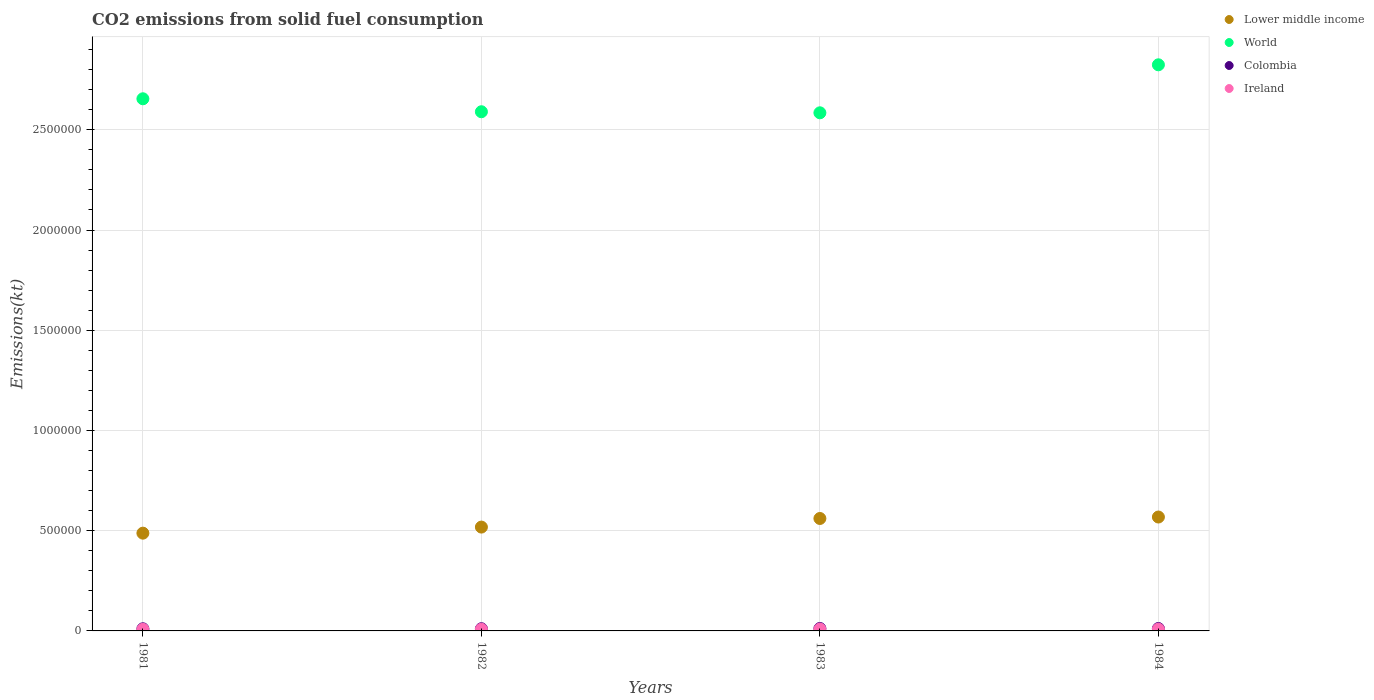What is the amount of CO2 emitted in Colombia in 1981?
Provide a short and direct response. 1.07e+04. Across all years, what is the maximum amount of CO2 emitted in World?
Your answer should be compact. 2.82e+06. Across all years, what is the minimum amount of CO2 emitted in Ireland?
Your answer should be very brief. 7920.72. What is the total amount of CO2 emitted in Lower middle income in the graph?
Ensure brevity in your answer.  2.13e+06. What is the difference between the amount of CO2 emitted in Ireland in 1983 and that in 1984?
Your response must be concise. 473.04. What is the difference between the amount of CO2 emitted in World in 1984 and the amount of CO2 emitted in Ireland in 1982?
Your answer should be very brief. 2.82e+06. What is the average amount of CO2 emitted in Colombia per year?
Give a very brief answer. 1.15e+04. In the year 1983, what is the difference between the amount of CO2 emitted in Colombia and amount of CO2 emitted in Ireland?
Offer a very short reply. 2922.6. What is the ratio of the amount of CO2 emitted in Colombia in 1981 to that in 1984?
Ensure brevity in your answer.  0.89. Is the amount of CO2 emitted in Ireland in 1983 less than that in 1984?
Offer a terse response. No. Is the difference between the amount of CO2 emitted in Colombia in 1982 and 1983 greater than the difference between the amount of CO2 emitted in Ireland in 1982 and 1983?
Ensure brevity in your answer.  No. What is the difference between the highest and the second highest amount of CO2 emitted in Lower middle income?
Give a very brief answer. 7272.31. What is the difference between the highest and the lowest amount of CO2 emitted in Colombia?
Your answer should be compact. 1477.8. Is the sum of the amount of CO2 emitted in World in 1981 and 1982 greater than the maximum amount of CO2 emitted in Ireland across all years?
Provide a short and direct response. Yes. How many dotlines are there?
Offer a very short reply. 4. Are the values on the major ticks of Y-axis written in scientific E-notation?
Your answer should be very brief. No. Does the graph contain any zero values?
Offer a very short reply. No. What is the title of the graph?
Your answer should be compact. CO2 emissions from solid fuel consumption. Does "Chad" appear as one of the legend labels in the graph?
Keep it short and to the point. No. What is the label or title of the Y-axis?
Offer a very short reply. Emissions(kt). What is the Emissions(kt) in Lower middle income in 1981?
Ensure brevity in your answer.  4.88e+05. What is the Emissions(kt) in World in 1981?
Your answer should be very brief. 2.65e+06. What is the Emissions(kt) of Colombia in 1981?
Your response must be concise. 1.07e+04. What is the Emissions(kt) of Ireland in 1981?
Your response must be concise. 7920.72. What is the Emissions(kt) in Lower middle income in 1982?
Your response must be concise. 5.18e+05. What is the Emissions(kt) in World in 1982?
Your answer should be compact. 2.59e+06. What is the Emissions(kt) in Colombia in 1982?
Offer a terse response. 1.10e+04. What is the Emissions(kt) of Ireland in 1982?
Offer a very short reply. 8360.76. What is the Emissions(kt) of Lower middle income in 1983?
Make the answer very short. 5.61e+05. What is the Emissions(kt) of World in 1983?
Your answer should be very brief. 2.58e+06. What is the Emissions(kt) of Colombia in 1983?
Offer a very short reply. 1.21e+04. What is the Emissions(kt) in Ireland in 1983?
Your response must be concise. 9226.17. What is the Emissions(kt) of Lower middle income in 1984?
Provide a succinct answer. 5.68e+05. What is the Emissions(kt) of World in 1984?
Make the answer very short. 2.82e+06. What is the Emissions(kt) of Colombia in 1984?
Offer a very short reply. 1.20e+04. What is the Emissions(kt) in Ireland in 1984?
Provide a succinct answer. 8753.13. Across all years, what is the maximum Emissions(kt) in Lower middle income?
Offer a very short reply. 5.68e+05. Across all years, what is the maximum Emissions(kt) of World?
Make the answer very short. 2.82e+06. Across all years, what is the maximum Emissions(kt) in Colombia?
Provide a short and direct response. 1.21e+04. Across all years, what is the maximum Emissions(kt) of Ireland?
Provide a succinct answer. 9226.17. Across all years, what is the minimum Emissions(kt) of Lower middle income?
Provide a short and direct response. 4.88e+05. Across all years, what is the minimum Emissions(kt) in World?
Your response must be concise. 2.58e+06. Across all years, what is the minimum Emissions(kt) of Colombia?
Make the answer very short. 1.07e+04. Across all years, what is the minimum Emissions(kt) in Ireland?
Offer a very short reply. 7920.72. What is the total Emissions(kt) of Lower middle income in the graph?
Make the answer very short. 2.13e+06. What is the total Emissions(kt) of World in the graph?
Provide a short and direct response. 1.07e+07. What is the total Emissions(kt) of Colombia in the graph?
Your answer should be compact. 4.58e+04. What is the total Emissions(kt) of Ireland in the graph?
Provide a succinct answer. 3.43e+04. What is the difference between the Emissions(kt) of Lower middle income in 1981 and that in 1982?
Provide a succinct answer. -3.03e+04. What is the difference between the Emissions(kt) of World in 1981 and that in 1982?
Keep it short and to the point. 6.47e+04. What is the difference between the Emissions(kt) of Colombia in 1981 and that in 1982?
Keep it short and to the point. -326.36. What is the difference between the Emissions(kt) of Ireland in 1981 and that in 1982?
Your answer should be very brief. -440.04. What is the difference between the Emissions(kt) in Lower middle income in 1981 and that in 1983?
Make the answer very short. -7.32e+04. What is the difference between the Emissions(kt) in World in 1981 and that in 1983?
Ensure brevity in your answer.  7.00e+04. What is the difference between the Emissions(kt) of Colombia in 1981 and that in 1983?
Make the answer very short. -1477.8. What is the difference between the Emissions(kt) of Ireland in 1981 and that in 1983?
Provide a short and direct response. -1305.45. What is the difference between the Emissions(kt) of Lower middle income in 1981 and that in 1984?
Your response must be concise. -8.05e+04. What is the difference between the Emissions(kt) of World in 1981 and that in 1984?
Keep it short and to the point. -1.70e+05. What is the difference between the Emissions(kt) in Colombia in 1981 and that in 1984?
Offer a terse response. -1334.79. What is the difference between the Emissions(kt) of Ireland in 1981 and that in 1984?
Offer a very short reply. -832.41. What is the difference between the Emissions(kt) of Lower middle income in 1982 and that in 1983?
Make the answer very short. -4.29e+04. What is the difference between the Emissions(kt) in World in 1982 and that in 1983?
Keep it short and to the point. 5262.15. What is the difference between the Emissions(kt) of Colombia in 1982 and that in 1983?
Ensure brevity in your answer.  -1151.44. What is the difference between the Emissions(kt) of Ireland in 1982 and that in 1983?
Give a very brief answer. -865.41. What is the difference between the Emissions(kt) in Lower middle income in 1982 and that in 1984?
Provide a short and direct response. -5.02e+04. What is the difference between the Emissions(kt) of World in 1982 and that in 1984?
Your response must be concise. -2.34e+05. What is the difference between the Emissions(kt) of Colombia in 1982 and that in 1984?
Ensure brevity in your answer.  -1008.42. What is the difference between the Emissions(kt) of Ireland in 1982 and that in 1984?
Your answer should be very brief. -392.37. What is the difference between the Emissions(kt) of Lower middle income in 1983 and that in 1984?
Keep it short and to the point. -7272.31. What is the difference between the Emissions(kt) of World in 1983 and that in 1984?
Ensure brevity in your answer.  -2.39e+05. What is the difference between the Emissions(kt) in Colombia in 1983 and that in 1984?
Make the answer very short. 143.01. What is the difference between the Emissions(kt) of Ireland in 1983 and that in 1984?
Give a very brief answer. 473.04. What is the difference between the Emissions(kt) of Lower middle income in 1981 and the Emissions(kt) of World in 1982?
Your answer should be very brief. -2.10e+06. What is the difference between the Emissions(kt) of Lower middle income in 1981 and the Emissions(kt) of Colombia in 1982?
Your answer should be compact. 4.77e+05. What is the difference between the Emissions(kt) of Lower middle income in 1981 and the Emissions(kt) of Ireland in 1982?
Your answer should be compact. 4.79e+05. What is the difference between the Emissions(kt) of World in 1981 and the Emissions(kt) of Colombia in 1982?
Provide a succinct answer. 2.64e+06. What is the difference between the Emissions(kt) in World in 1981 and the Emissions(kt) in Ireland in 1982?
Make the answer very short. 2.65e+06. What is the difference between the Emissions(kt) of Colombia in 1981 and the Emissions(kt) of Ireland in 1982?
Provide a succinct answer. 2310.21. What is the difference between the Emissions(kt) of Lower middle income in 1981 and the Emissions(kt) of World in 1983?
Make the answer very short. -2.10e+06. What is the difference between the Emissions(kt) of Lower middle income in 1981 and the Emissions(kt) of Colombia in 1983?
Offer a very short reply. 4.76e+05. What is the difference between the Emissions(kt) in Lower middle income in 1981 and the Emissions(kt) in Ireland in 1983?
Provide a short and direct response. 4.78e+05. What is the difference between the Emissions(kt) of World in 1981 and the Emissions(kt) of Colombia in 1983?
Give a very brief answer. 2.64e+06. What is the difference between the Emissions(kt) of World in 1981 and the Emissions(kt) of Ireland in 1983?
Offer a very short reply. 2.65e+06. What is the difference between the Emissions(kt) in Colombia in 1981 and the Emissions(kt) in Ireland in 1983?
Provide a short and direct response. 1444.8. What is the difference between the Emissions(kt) of Lower middle income in 1981 and the Emissions(kt) of World in 1984?
Your answer should be very brief. -2.34e+06. What is the difference between the Emissions(kt) in Lower middle income in 1981 and the Emissions(kt) in Colombia in 1984?
Provide a short and direct response. 4.76e+05. What is the difference between the Emissions(kt) in Lower middle income in 1981 and the Emissions(kt) in Ireland in 1984?
Give a very brief answer. 4.79e+05. What is the difference between the Emissions(kt) in World in 1981 and the Emissions(kt) in Colombia in 1984?
Keep it short and to the point. 2.64e+06. What is the difference between the Emissions(kt) of World in 1981 and the Emissions(kt) of Ireland in 1984?
Keep it short and to the point. 2.65e+06. What is the difference between the Emissions(kt) of Colombia in 1981 and the Emissions(kt) of Ireland in 1984?
Your answer should be very brief. 1917.84. What is the difference between the Emissions(kt) of Lower middle income in 1982 and the Emissions(kt) of World in 1983?
Offer a terse response. -2.07e+06. What is the difference between the Emissions(kt) in Lower middle income in 1982 and the Emissions(kt) in Colombia in 1983?
Your answer should be very brief. 5.06e+05. What is the difference between the Emissions(kt) in Lower middle income in 1982 and the Emissions(kt) in Ireland in 1983?
Keep it short and to the point. 5.09e+05. What is the difference between the Emissions(kt) of World in 1982 and the Emissions(kt) of Colombia in 1983?
Offer a terse response. 2.58e+06. What is the difference between the Emissions(kt) in World in 1982 and the Emissions(kt) in Ireland in 1983?
Provide a short and direct response. 2.58e+06. What is the difference between the Emissions(kt) of Colombia in 1982 and the Emissions(kt) of Ireland in 1983?
Your answer should be very brief. 1771.16. What is the difference between the Emissions(kt) in Lower middle income in 1982 and the Emissions(kt) in World in 1984?
Give a very brief answer. -2.31e+06. What is the difference between the Emissions(kt) of Lower middle income in 1982 and the Emissions(kt) of Colombia in 1984?
Keep it short and to the point. 5.06e+05. What is the difference between the Emissions(kt) of Lower middle income in 1982 and the Emissions(kt) of Ireland in 1984?
Your answer should be very brief. 5.09e+05. What is the difference between the Emissions(kt) in World in 1982 and the Emissions(kt) in Colombia in 1984?
Provide a short and direct response. 2.58e+06. What is the difference between the Emissions(kt) of World in 1982 and the Emissions(kt) of Ireland in 1984?
Offer a terse response. 2.58e+06. What is the difference between the Emissions(kt) in Colombia in 1982 and the Emissions(kt) in Ireland in 1984?
Make the answer very short. 2244.2. What is the difference between the Emissions(kt) in Lower middle income in 1983 and the Emissions(kt) in World in 1984?
Make the answer very short. -2.26e+06. What is the difference between the Emissions(kt) of Lower middle income in 1983 and the Emissions(kt) of Colombia in 1984?
Provide a short and direct response. 5.49e+05. What is the difference between the Emissions(kt) in Lower middle income in 1983 and the Emissions(kt) in Ireland in 1984?
Give a very brief answer. 5.52e+05. What is the difference between the Emissions(kt) in World in 1983 and the Emissions(kt) in Colombia in 1984?
Provide a short and direct response. 2.57e+06. What is the difference between the Emissions(kt) of World in 1983 and the Emissions(kt) of Ireland in 1984?
Provide a short and direct response. 2.58e+06. What is the difference between the Emissions(kt) of Colombia in 1983 and the Emissions(kt) of Ireland in 1984?
Keep it short and to the point. 3395.64. What is the average Emissions(kt) in Lower middle income per year?
Ensure brevity in your answer.  5.34e+05. What is the average Emissions(kt) in World per year?
Give a very brief answer. 2.66e+06. What is the average Emissions(kt) in Colombia per year?
Your answer should be compact. 1.15e+04. What is the average Emissions(kt) of Ireland per year?
Offer a very short reply. 8565.2. In the year 1981, what is the difference between the Emissions(kt) in Lower middle income and Emissions(kt) in World?
Offer a very short reply. -2.17e+06. In the year 1981, what is the difference between the Emissions(kt) of Lower middle income and Emissions(kt) of Colombia?
Your answer should be compact. 4.77e+05. In the year 1981, what is the difference between the Emissions(kt) of Lower middle income and Emissions(kt) of Ireland?
Keep it short and to the point. 4.80e+05. In the year 1981, what is the difference between the Emissions(kt) in World and Emissions(kt) in Colombia?
Your answer should be very brief. 2.64e+06. In the year 1981, what is the difference between the Emissions(kt) in World and Emissions(kt) in Ireland?
Ensure brevity in your answer.  2.65e+06. In the year 1981, what is the difference between the Emissions(kt) in Colombia and Emissions(kt) in Ireland?
Your response must be concise. 2750.25. In the year 1982, what is the difference between the Emissions(kt) in Lower middle income and Emissions(kt) in World?
Ensure brevity in your answer.  -2.07e+06. In the year 1982, what is the difference between the Emissions(kt) in Lower middle income and Emissions(kt) in Colombia?
Provide a short and direct response. 5.07e+05. In the year 1982, what is the difference between the Emissions(kt) of Lower middle income and Emissions(kt) of Ireland?
Provide a short and direct response. 5.10e+05. In the year 1982, what is the difference between the Emissions(kt) in World and Emissions(kt) in Colombia?
Offer a terse response. 2.58e+06. In the year 1982, what is the difference between the Emissions(kt) of World and Emissions(kt) of Ireland?
Provide a short and direct response. 2.58e+06. In the year 1982, what is the difference between the Emissions(kt) in Colombia and Emissions(kt) in Ireland?
Offer a terse response. 2636.57. In the year 1983, what is the difference between the Emissions(kt) in Lower middle income and Emissions(kt) in World?
Provide a succinct answer. -2.02e+06. In the year 1983, what is the difference between the Emissions(kt) in Lower middle income and Emissions(kt) in Colombia?
Provide a short and direct response. 5.49e+05. In the year 1983, what is the difference between the Emissions(kt) in Lower middle income and Emissions(kt) in Ireland?
Your answer should be compact. 5.52e+05. In the year 1983, what is the difference between the Emissions(kt) in World and Emissions(kt) in Colombia?
Your response must be concise. 2.57e+06. In the year 1983, what is the difference between the Emissions(kt) of World and Emissions(kt) of Ireland?
Offer a very short reply. 2.58e+06. In the year 1983, what is the difference between the Emissions(kt) of Colombia and Emissions(kt) of Ireland?
Provide a short and direct response. 2922.6. In the year 1984, what is the difference between the Emissions(kt) in Lower middle income and Emissions(kt) in World?
Provide a short and direct response. -2.26e+06. In the year 1984, what is the difference between the Emissions(kt) of Lower middle income and Emissions(kt) of Colombia?
Offer a very short reply. 5.56e+05. In the year 1984, what is the difference between the Emissions(kt) of Lower middle income and Emissions(kt) of Ireland?
Make the answer very short. 5.59e+05. In the year 1984, what is the difference between the Emissions(kt) of World and Emissions(kt) of Colombia?
Keep it short and to the point. 2.81e+06. In the year 1984, what is the difference between the Emissions(kt) of World and Emissions(kt) of Ireland?
Provide a succinct answer. 2.82e+06. In the year 1984, what is the difference between the Emissions(kt) of Colombia and Emissions(kt) of Ireland?
Make the answer very short. 3252.63. What is the ratio of the Emissions(kt) in Lower middle income in 1981 to that in 1982?
Your answer should be compact. 0.94. What is the ratio of the Emissions(kt) in Colombia in 1981 to that in 1982?
Your response must be concise. 0.97. What is the ratio of the Emissions(kt) of Ireland in 1981 to that in 1982?
Your response must be concise. 0.95. What is the ratio of the Emissions(kt) of Lower middle income in 1981 to that in 1983?
Your answer should be compact. 0.87. What is the ratio of the Emissions(kt) of World in 1981 to that in 1983?
Offer a terse response. 1.03. What is the ratio of the Emissions(kt) of Colombia in 1981 to that in 1983?
Make the answer very short. 0.88. What is the ratio of the Emissions(kt) of Ireland in 1981 to that in 1983?
Give a very brief answer. 0.86. What is the ratio of the Emissions(kt) of Lower middle income in 1981 to that in 1984?
Provide a succinct answer. 0.86. What is the ratio of the Emissions(kt) of World in 1981 to that in 1984?
Make the answer very short. 0.94. What is the ratio of the Emissions(kt) of Colombia in 1981 to that in 1984?
Your answer should be very brief. 0.89. What is the ratio of the Emissions(kt) of Ireland in 1981 to that in 1984?
Provide a succinct answer. 0.9. What is the ratio of the Emissions(kt) in Lower middle income in 1982 to that in 1983?
Your answer should be very brief. 0.92. What is the ratio of the Emissions(kt) of World in 1982 to that in 1983?
Your answer should be very brief. 1. What is the ratio of the Emissions(kt) in Colombia in 1982 to that in 1983?
Make the answer very short. 0.91. What is the ratio of the Emissions(kt) of Ireland in 1982 to that in 1983?
Offer a terse response. 0.91. What is the ratio of the Emissions(kt) in Lower middle income in 1982 to that in 1984?
Make the answer very short. 0.91. What is the ratio of the Emissions(kt) in World in 1982 to that in 1984?
Offer a terse response. 0.92. What is the ratio of the Emissions(kt) of Colombia in 1982 to that in 1984?
Make the answer very short. 0.92. What is the ratio of the Emissions(kt) in Ireland in 1982 to that in 1984?
Provide a succinct answer. 0.96. What is the ratio of the Emissions(kt) of Lower middle income in 1983 to that in 1984?
Offer a very short reply. 0.99. What is the ratio of the Emissions(kt) of World in 1983 to that in 1984?
Keep it short and to the point. 0.92. What is the ratio of the Emissions(kt) in Colombia in 1983 to that in 1984?
Keep it short and to the point. 1.01. What is the ratio of the Emissions(kt) in Ireland in 1983 to that in 1984?
Offer a terse response. 1.05. What is the difference between the highest and the second highest Emissions(kt) of Lower middle income?
Give a very brief answer. 7272.31. What is the difference between the highest and the second highest Emissions(kt) in World?
Your answer should be compact. 1.70e+05. What is the difference between the highest and the second highest Emissions(kt) of Colombia?
Your answer should be very brief. 143.01. What is the difference between the highest and the second highest Emissions(kt) of Ireland?
Your answer should be compact. 473.04. What is the difference between the highest and the lowest Emissions(kt) in Lower middle income?
Your answer should be compact. 8.05e+04. What is the difference between the highest and the lowest Emissions(kt) of World?
Offer a very short reply. 2.39e+05. What is the difference between the highest and the lowest Emissions(kt) in Colombia?
Give a very brief answer. 1477.8. What is the difference between the highest and the lowest Emissions(kt) in Ireland?
Provide a succinct answer. 1305.45. 